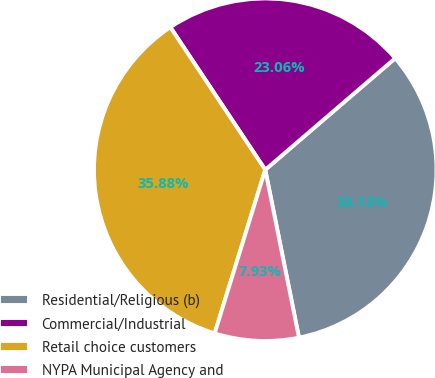<chart> <loc_0><loc_0><loc_500><loc_500><pie_chart><fcel>Residential/Religious (b)<fcel>Commercial/Industrial<fcel>Retail choice customers<fcel>NYPA Municipal Agency and<nl><fcel>33.13%<fcel>23.06%<fcel>35.88%<fcel>7.93%<nl></chart> 